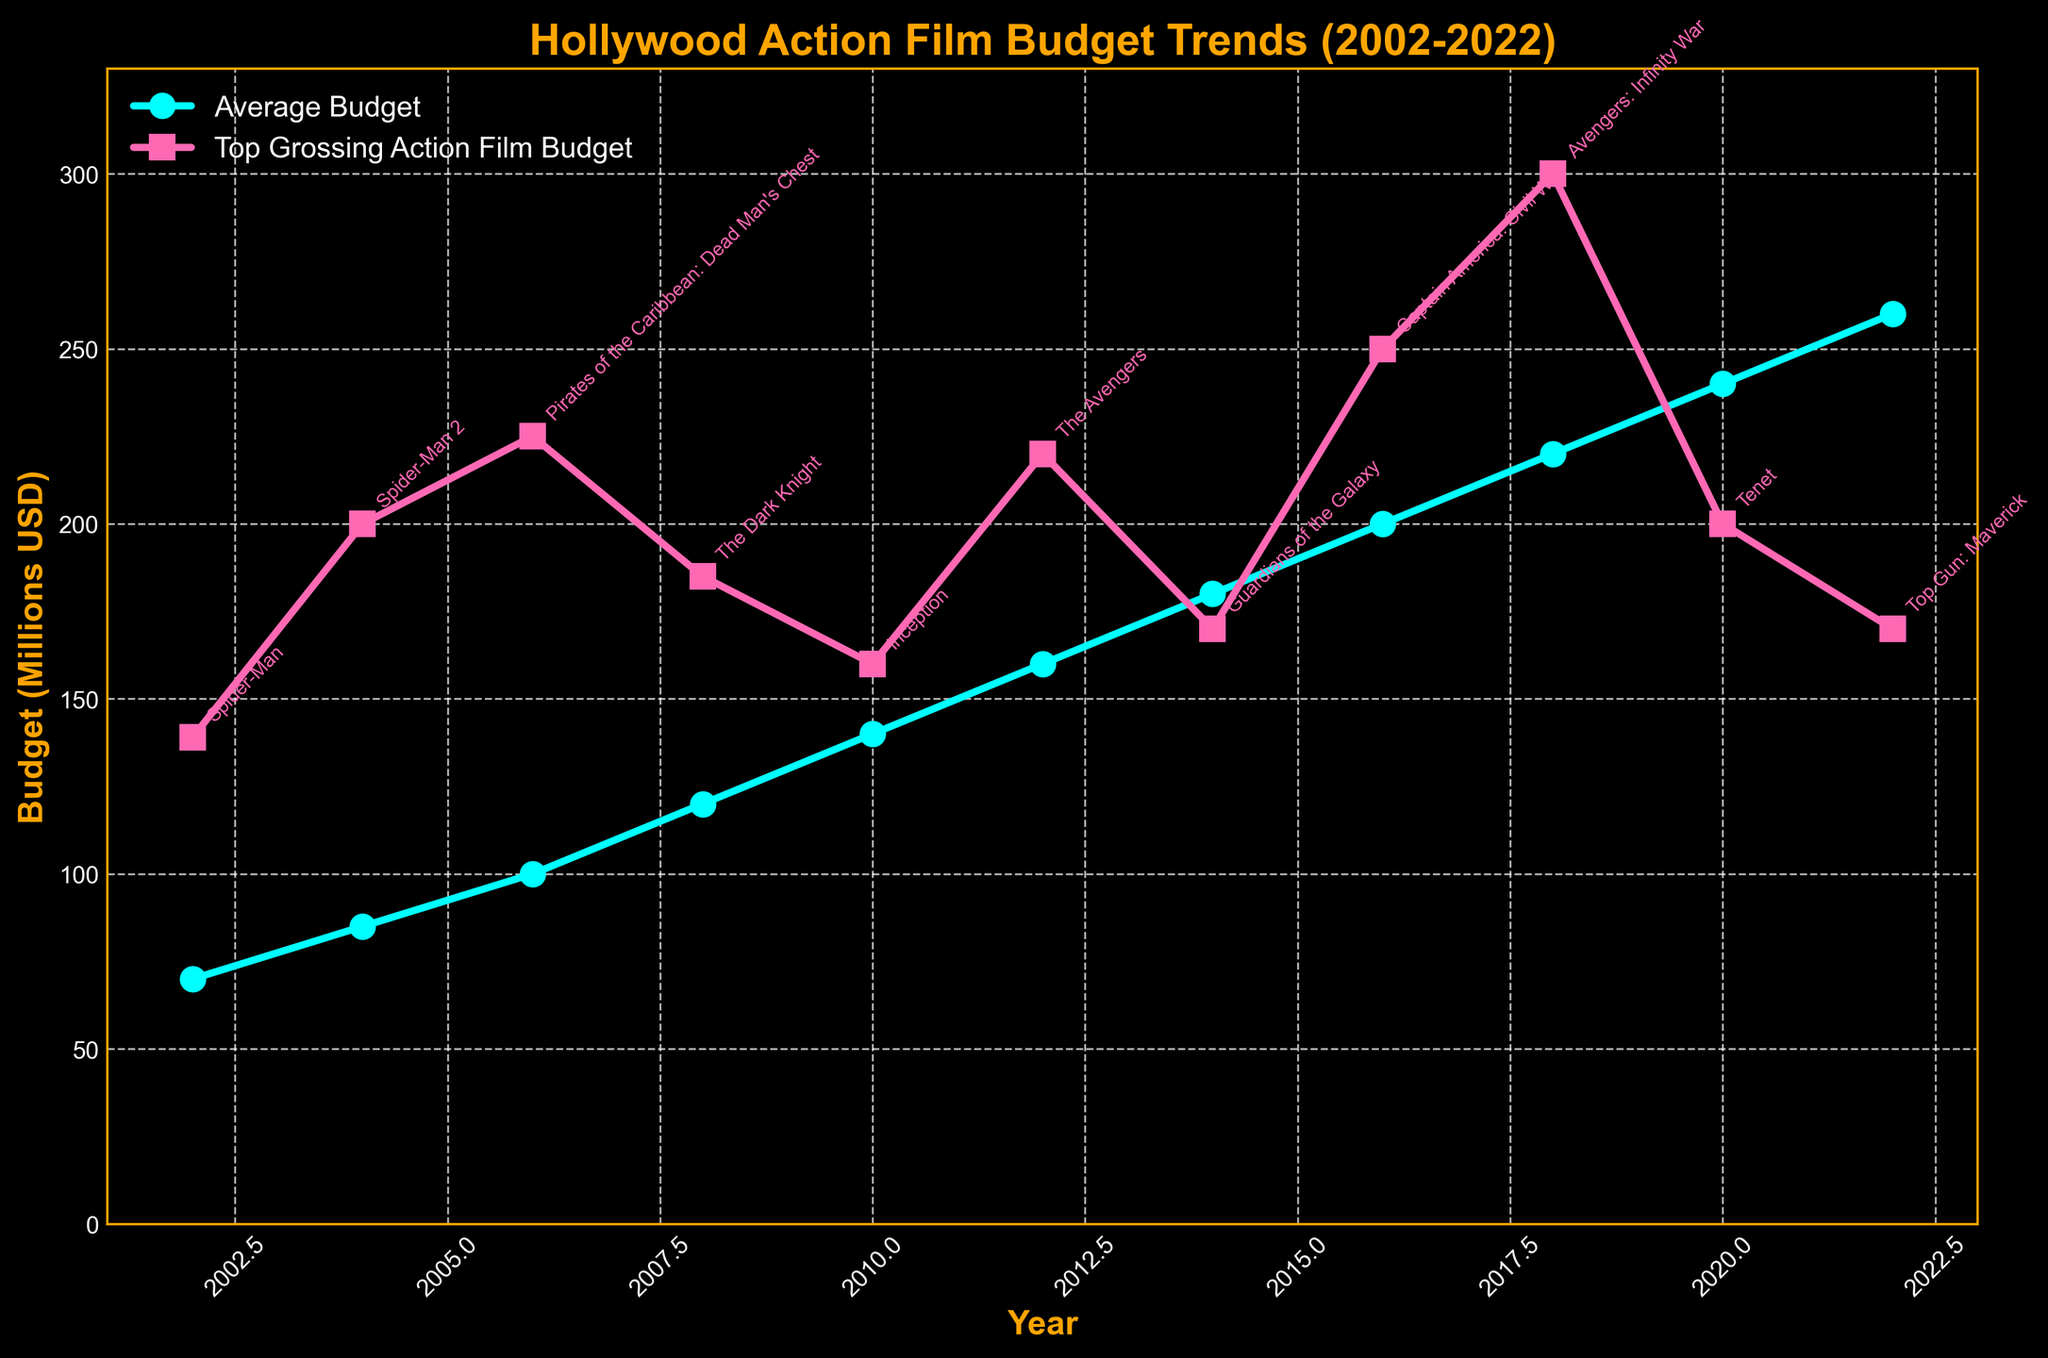Which year had the highest average budget for major action films? The plot shows the Average Budget (Millions USD) across different years. Locate the highest point on the 'Average Budget' line and note its corresponding year.
Answer: 2022 Compare the budget of the top grossing action films between 2008 and 2020. Which year had a higher budget? Identify the budgets for the top grossing action films in 2008 and 2020 in the plot. Compare the budget values to determine which is higher.
Answer: 2008 Between 2010 and 2016, how much did the average budget for action films increase? Locate the average budget values for the years 2010 and 2016. Subtract the 2010 value from the 2016 value to find the increase.
Answer: 60 million USD What is the difference between the budgets of "The Dark Knight" (2008) and "Top Gun: Maverick" (2022)? Find the budget values for "The Dark Knight" and "Top Gun: Maverick" on the plot. Calculate the difference by subtracting the 2008 value from the 2022 value.
Answer: -15 million USD What was the budget of the top grossing film in the year with the lowest average budget? Identify the year with the lowest average budget on the plot. Look for the budget of the top grossing action film in that year according to the corresponding data point.
Answer: 139 million USD Which year had the smallest gap between the average budget and the budget of the top grossing action film? Calculate the difference between the 'Average Budget' and 'Top Grossing Action Film Budget' for each year by visual estimation from the plot. Identify the year that has the smallest difference.
Answer: 2014 How did the average budget trend between 2012 and 2018? Examine the 'Average Budget' line between the years 2012 and 2018 on the plot to describe the trend, whether it is increasing, decreasing, or stable.
Answer: Increasing What's the midpoint year between 2004 and 2022 and what were the budgets for both average and top-grossing action films in that year? Find the midpoint year: (2004 + 2022) / 2 = 2013. Use the closest available data (2014) and check both budgets in that year from the plot.
Answer: 2014, 180 million USD (average), 170 million USD (top-grossing) In which year did the budget of the top grossing action film exceed 200 million USD for the first time? Identify the first year on the 'Top Grossing Action Film Budget' line where the value exceeds 200 million USD.
Answer: 2006 